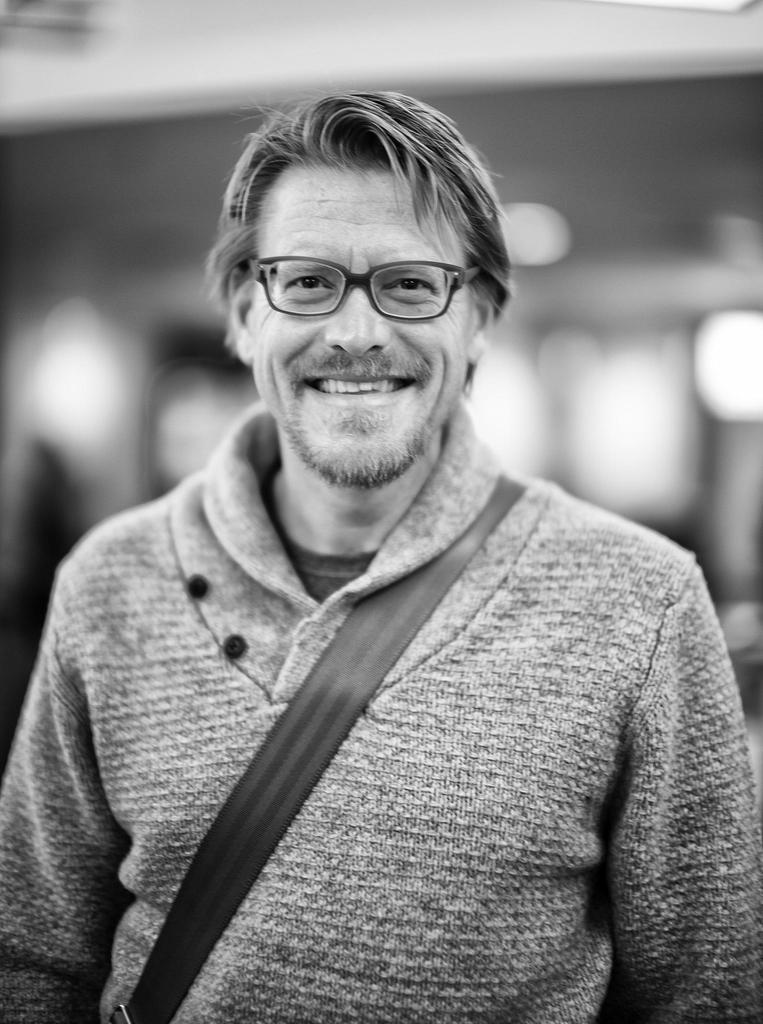What is the main subject of the image? The main subject of the image is a man. What is the man wearing in the image? The man is wearing a bag and a belt in the image. What is the man's facial expression in the image? The man is smiling in the image. What is visible in the background of the image? There is a building visible in the background of the image, but it is not clear. What is the man's opinion on the hour in the image? There is no indication of the man's opinion on the hour in the image. 